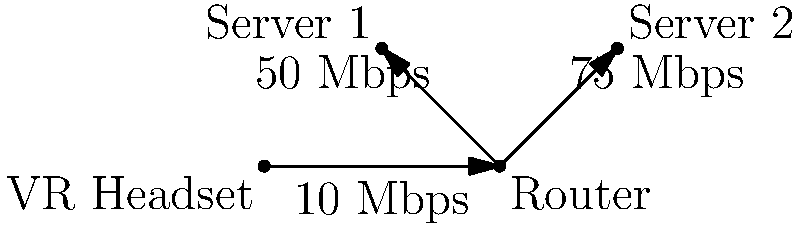A virtual reality streaming setup consists of a VR headset connected to a router, which in turn connects to two servers. The connection between the VR headset and router has a bandwidth of 10 Mbps, while the connections from the router to Server 1 and Server 2 have bandwidths of 50 Mbps and 75 Mbps, respectively. If the VR application requires a minimum of 15 Mbps to function properly, what is the maximum number of simultaneous VR streams that can be supported by this network configuration? To solve this problem, we need to follow these steps:

1. Identify the bottleneck in the network:
   The connection between the VR headset and the router has the lowest bandwidth (10 Mbps), making it the bottleneck.

2. Calculate the total available bandwidth from the servers:
   Server 1: 50 Mbps
   Server 2: 75 Mbps
   Total: 50 + 75 = 125 Mbps

3. Determine the limiting factor:
   The bottleneck (10 Mbps) is less than the total server bandwidth (125 Mbps), so the VR headset-router connection is the limiting factor.

4. Calculate the maximum number of streams:
   Let $x$ be the number of streams.
   Each stream requires 15 Mbps.
   The total required bandwidth cannot exceed the bottleneck bandwidth:
   
   $15x \leq 10$
   
   $x \leq \frac{10}{15} \approx 0.67$

5. Round down to the nearest whole number:
   The maximum number of simultaneous streams is 0.

Therefore, this network configuration cannot support any VR streams that require 15 Mbps, as the bottleneck bandwidth (10 Mbps) is less than the minimum required bandwidth for a single stream.
Answer: 0 streams 